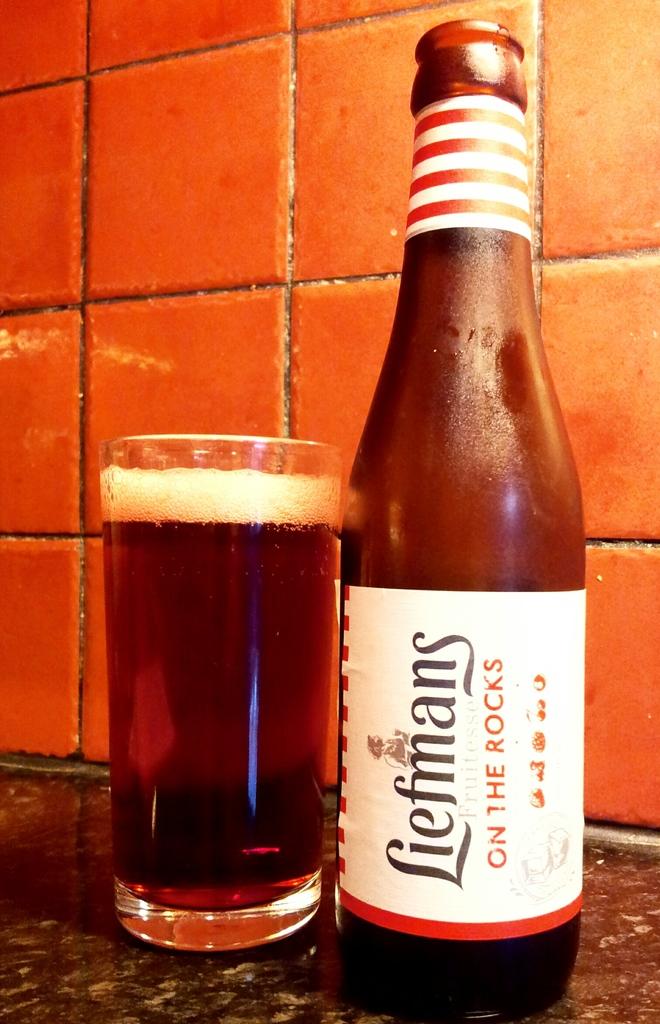What is the drink on?
Your answer should be very brief. Answering does not require reading text in the image. What brand is the beer?
Offer a very short reply. Liefmans. 